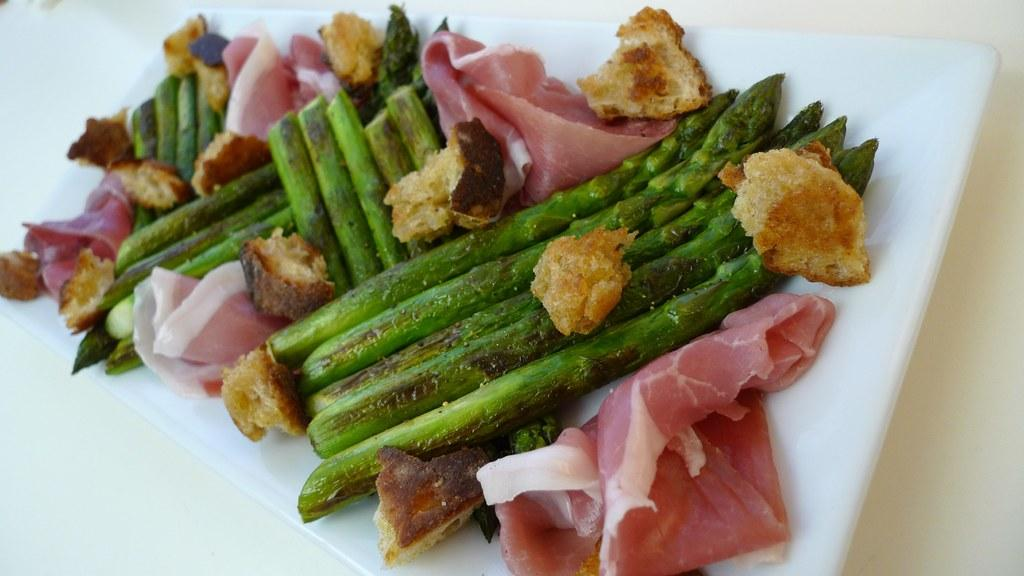What type of food can be seen in the image? There are chopped vegetables, meat, and bread in the image. How are the chopped vegetables, meat, and bread arranged in the image? They are all on a plate in the image. Where is the plate with the chopped vegetables, meat, and bread located? The plate is on a table in the image. What type of crime is being committed in the image? There is no crime being committed in the image; it features chopped vegetables, meat, and bread on a plate. What type of pleasure can be derived from the food in the image? The image does not convey any specific pleasure derived from the food; it simply shows the food items on a plate. 